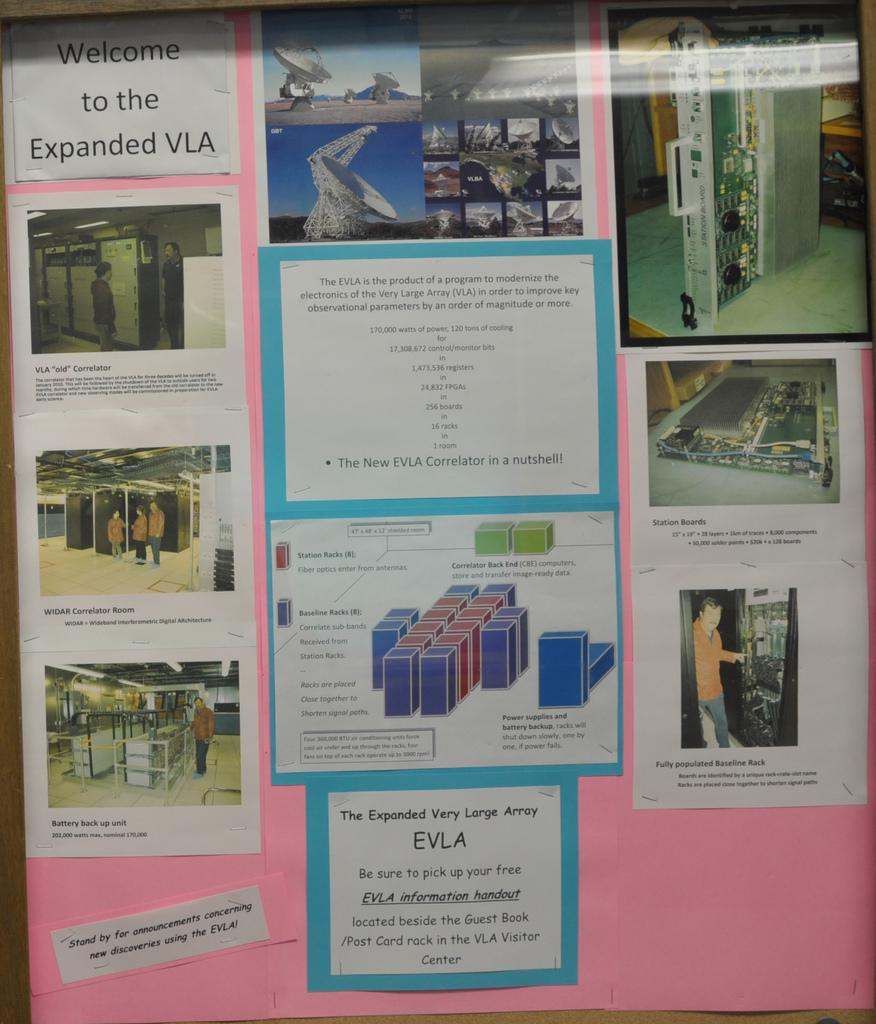What can be seen on the pink chart in the image? There are posters on the pink chart in the image. How many toes are visible on the posters in the image? There are no toes visible on the posters in the image, as they are not related to feet or toes. 